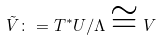<formula> <loc_0><loc_0><loc_500><loc_500>\tilde { V } \colon = T ^ { \ast } U \slash \Lambda \cong V</formula> 